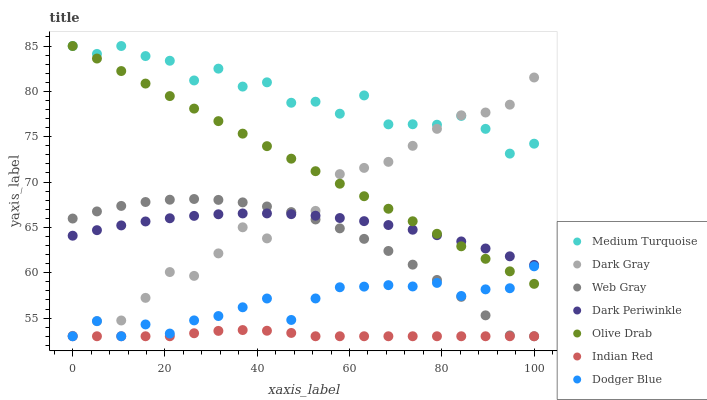Does Indian Red have the minimum area under the curve?
Answer yes or no. Yes. Does Medium Turquoise have the maximum area under the curve?
Answer yes or no. Yes. Does Dark Gray have the minimum area under the curve?
Answer yes or no. No. Does Dark Gray have the maximum area under the curve?
Answer yes or no. No. Is Olive Drab the smoothest?
Answer yes or no. Yes. Is Medium Turquoise the roughest?
Answer yes or no. Yes. Is Dark Gray the smoothest?
Answer yes or no. No. Is Dark Gray the roughest?
Answer yes or no. No. Does Web Gray have the lowest value?
Answer yes or no. Yes. Does Dark Gray have the lowest value?
Answer yes or no. No. Does Olive Drab have the highest value?
Answer yes or no. Yes. Does Dark Gray have the highest value?
Answer yes or no. No. Is Web Gray less than Olive Drab?
Answer yes or no. Yes. Is Dark Periwinkle greater than Dodger Blue?
Answer yes or no. Yes. Does Olive Drab intersect Medium Turquoise?
Answer yes or no. Yes. Is Olive Drab less than Medium Turquoise?
Answer yes or no. No. Is Olive Drab greater than Medium Turquoise?
Answer yes or no. No. Does Web Gray intersect Olive Drab?
Answer yes or no. No. 